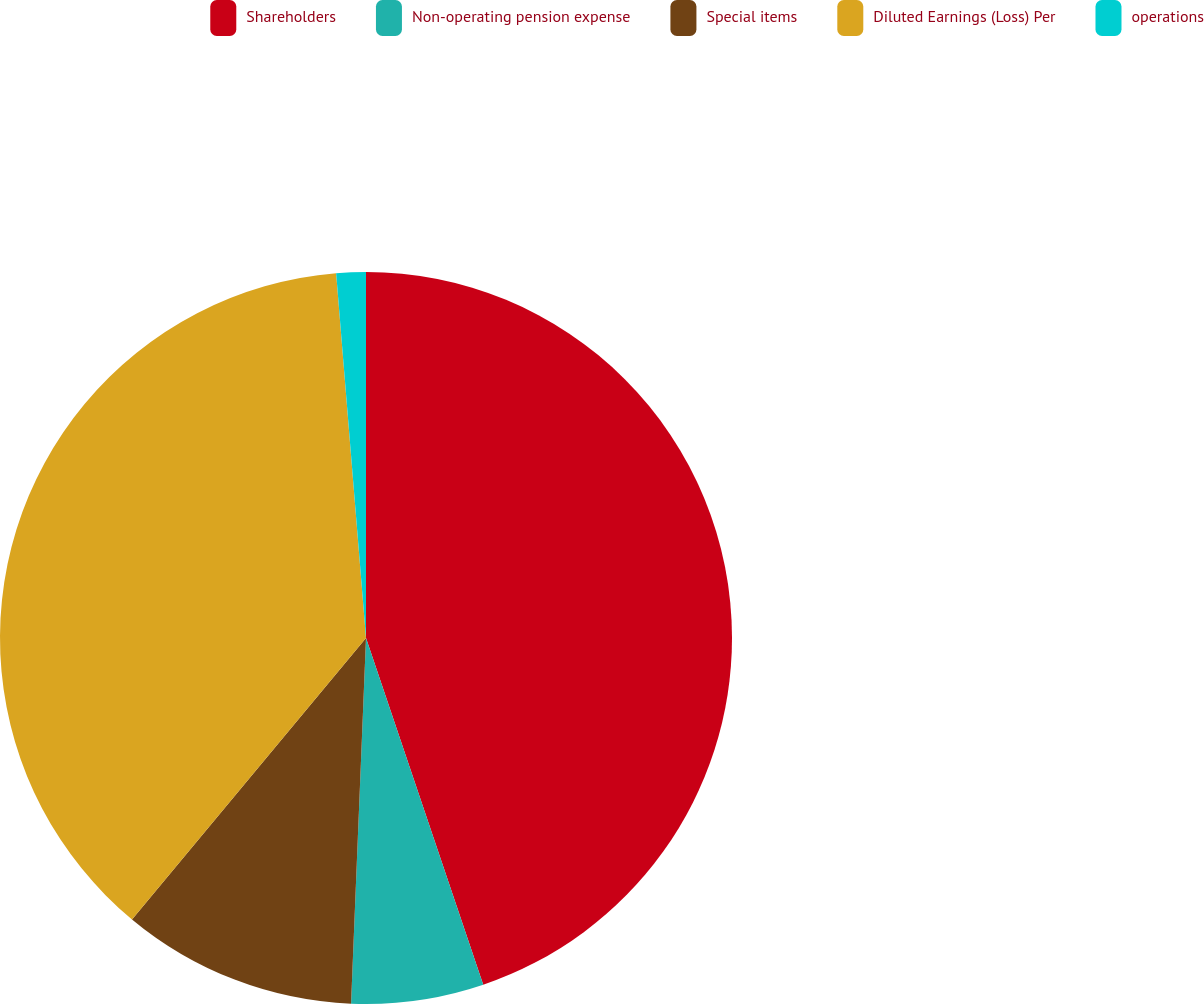<chart> <loc_0><loc_0><loc_500><loc_500><pie_chart><fcel>Shareholders<fcel>Non-operating pension expense<fcel>Special items<fcel>Diluted Earnings (Loss) Per<fcel>operations<nl><fcel>44.81%<fcel>5.84%<fcel>10.39%<fcel>37.66%<fcel>1.3%<nl></chart> 